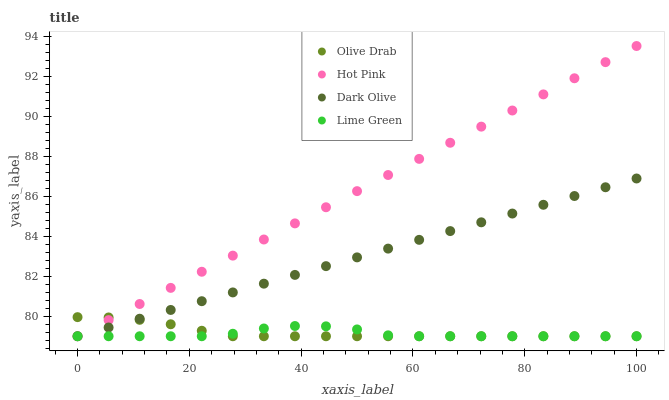Does Lime Green have the minimum area under the curve?
Answer yes or no. Yes. Does Hot Pink have the maximum area under the curve?
Answer yes or no. Yes. Does Hot Pink have the minimum area under the curve?
Answer yes or no. No. Does Lime Green have the maximum area under the curve?
Answer yes or no. No. Is Hot Pink the smoothest?
Answer yes or no. Yes. Is Lime Green the roughest?
Answer yes or no. Yes. Is Lime Green the smoothest?
Answer yes or no. No. Is Hot Pink the roughest?
Answer yes or no. No. Does Dark Olive have the lowest value?
Answer yes or no. Yes. Does Hot Pink have the highest value?
Answer yes or no. Yes. Does Lime Green have the highest value?
Answer yes or no. No. Does Hot Pink intersect Olive Drab?
Answer yes or no. Yes. Is Hot Pink less than Olive Drab?
Answer yes or no. No. Is Hot Pink greater than Olive Drab?
Answer yes or no. No. 